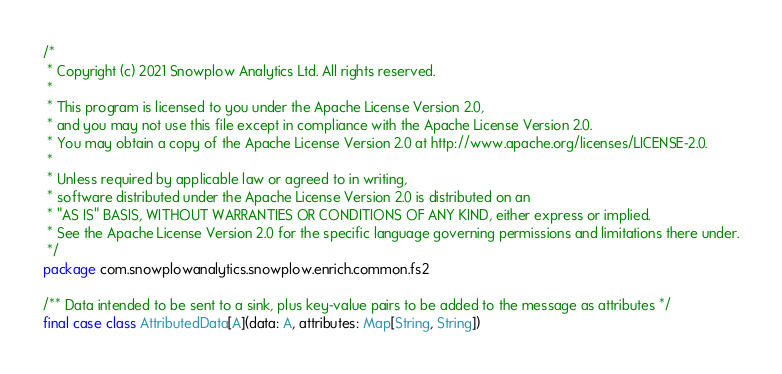<code> <loc_0><loc_0><loc_500><loc_500><_Scala_>/*
 * Copyright (c) 2021 Snowplow Analytics Ltd. All rights reserved.
 *
 * This program is licensed to you under the Apache License Version 2.0,
 * and you may not use this file except in compliance with the Apache License Version 2.0.
 * You may obtain a copy of the Apache License Version 2.0 at http://www.apache.org/licenses/LICENSE-2.0.
 *
 * Unless required by applicable law or agreed to in writing,
 * software distributed under the Apache License Version 2.0 is distributed on an
 * "AS IS" BASIS, WITHOUT WARRANTIES OR CONDITIONS OF ANY KIND, either express or implied.
 * See the Apache License Version 2.0 for the specific language governing permissions and limitations there under.
 */
package com.snowplowanalytics.snowplow.enrich.common.fs2

/** Data intended to be sent to a sink, plus key-value pairs to be added to the message as attributes */
final case class AttributedData[A](data: A, attributes: Map[String, String])
</code> 